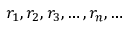Convert formula to latex. <formula><loc_0><loc_0><loc_500><loc_500>r _ { 1 } , r _ { 2 } , r _ { 3 } , \dots , r _ { n } , \dots</formula> 